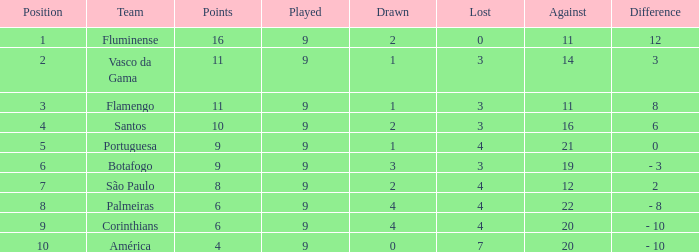Which Position has a Played larger than 9? None. 